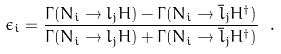<formula> <loc_0><loc_0><loc_500><loc_500>\epsilon _ { i } = \frac { \Gamma ( N _ { i } \rightarrow l _ { j } H ) - \Gamma ( N _ { i } \rightarrow \bar { l } _ { j } H ^ { \dagger } ) } { \Gamma ( N _ { i } \rightarrow l _ { j } H ) + \Gamma ( N _ { i } \rightarrow \bar { l } _ { j } H ^ { \dagger } ) } \ .</formula> 